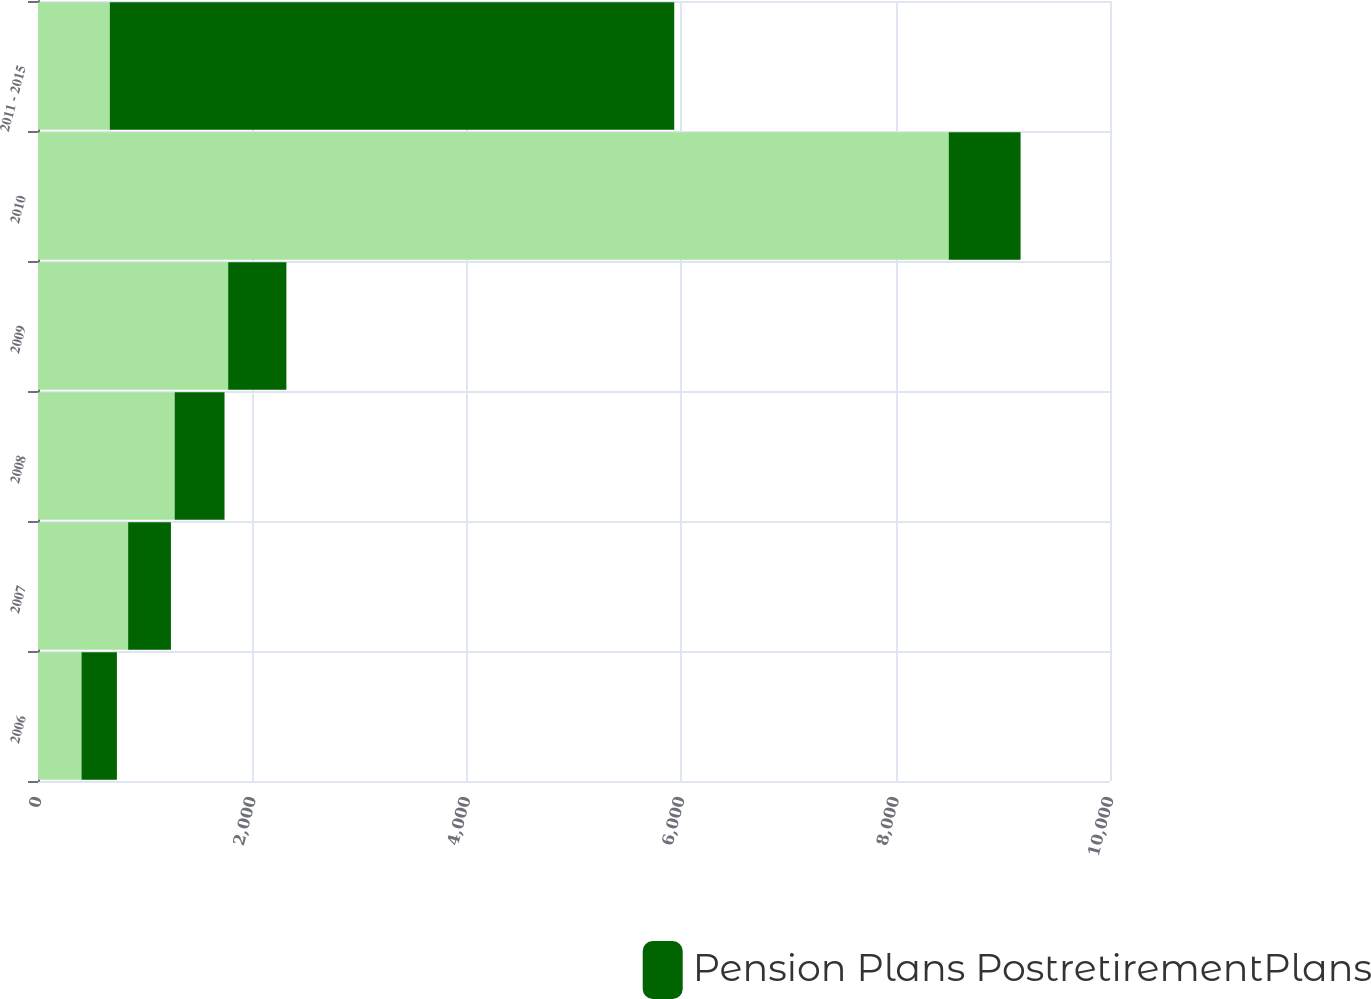Convert chart to OTSL. <chart><loc_0><loc_0><loc_500><loc_500><stacked_bar_chart><ecel><fcel>2006<fcel>2007<fcel>2008<fcel>2009<fcel>2010<fcel>2011 - 2015<nl><fcel>nan<fcel>406<fcel>841<fcel>1275<fcel>1774<fcel>8496<fcel>670<nl><fcel>Pension Plans PostretirementPlans<fcel>330<fcel>399<fcel>465<fcel>543<fcel>670<fcel>5265<nl></chart> 